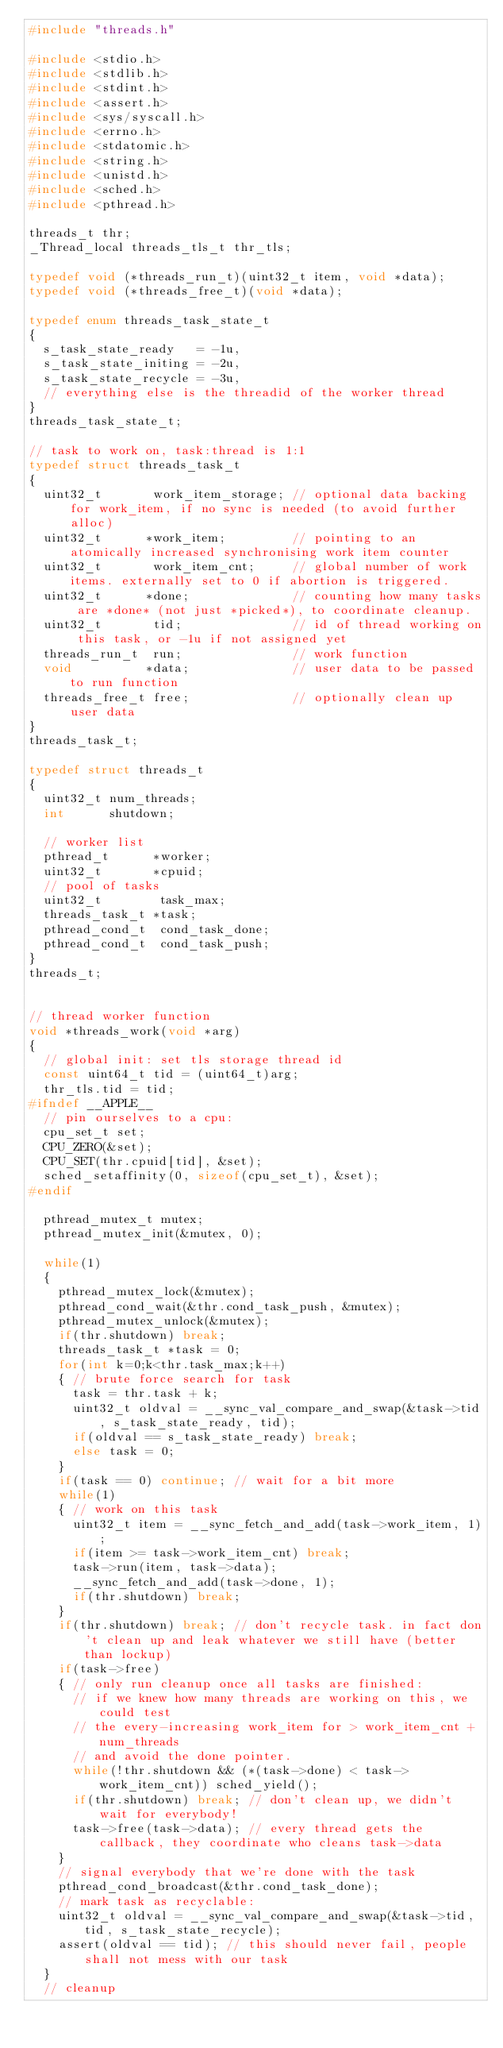<code> <loc_0><loc_0><loc_500><loc_500><_C_>#include "threads.h"

#include <stdio.h>
#include <stdlib.h>
#include <stdint.h>
#include <assert.h>
#include <sys/syscall.h>
#include <errno.h>
#include <stdatomic.h>
#include <string.h>
#include <unistd.h>
#include <sched.h>
#include <pthread.h>

threads_t thr;
_Thread_local threads_tls_t thr_tls;

typedef void (*threads_run_t)(uint32_t item, void *data);
typedef void (*threads_free_t)(void *data);

typedef enum threads_task_state_t
{
  s_task_state_ready   = -1u,
  s_task_state_initing = -2u,
  s_task_state_recycle = -3u,
  // everything else is the threadid of the worker thread
}
threads_task_state_t;

// task to work on, task:thread is 1:1
typedef struct threads_task_t
{
  uint32_t       work_item_storage; // optional data backing for work_item, if no sync is needed (to avoid further alloc)
  uint32_t      *work_item;         // pointing to an atomically increased synchronising work item counter
  uint32_t       work_item_cnt;     // global number of work items. externally set to 0 if abortion is triggered.
  uint32_t      *done;              // counting how many tasks are *done* (not just *picked*), to coordinate cleanup.
  uint32_t       tid;               // id of thread working on this task, or -1u if not assigned yet
  threads_run_t  run;               // work function
  void          *data;              // user data to be passed to run function
  threads_free_t free;              // optionally clean up user data
}
threads_task_t;

typedef struct threads_t
{
  uint32_t num_threads;
  int      shutdown;

  // worker list
  pthread_t      *worker;
  uint32_t       *cpuid;
  // pool of tasks
  uint32_t        task_max;
  threads_task_t *task;
  pthread_cond_t  cond_task_done;
  pthread_cond_t  cond_task_push;
}
threads_t;


// thread worker function
void *threads_work(void *arg)
{
  // global init: set tls storage thread id
  const uint64_t tid = (uint64_t)arg;
  thr_tls.tid = tid;
#ifndef __APPLE__
  // pin ourselves to a cpu:
  cpu_set_t set;
  CPU_ZERO(&set);
  CPU_SET(thr.cpuid[tid], &set);
  sched_setaffinity(0, sizeof(cpu_set_t), &set);
#endif

  pthread_mutex_t mutex;
  pthread_mutex_init(&mutex, 0);

  while(1)
  {
    pthread_mutex_lock(&mutex);
    pthread_cond_wait(&thr.cond_task_push, &mutex);
    pthread_mutex_unlock(&mutex);
    if(thr.shutdown) break;
    threads_task_t *task = 0;
    for(int k=0;k<thr.task_max;k++)
    { // brute force search for task
      task = thr.task + k;
      uint32_t oldval = __sync_val_compare_and_swap(&task->tid, s_task_state_ready, tid);
      if(oldval == s_task_state_ready) break;
      else task = 0;
    }
    if(task == 0) continue; // wait for a bit more
    while(1)
    { // work on this task
      uint32_t item = __sync_fetch_and_add(task->work_item, 1);
      if(item >= task->work_item_cnt) break;
      task->run(item, task->data);
      __sync_fetch_and_add(task->done, 1);
      if(thr.shutdown) break;
    }
    if(thr.shutdown) break; // don't recycle task. in fact don't clean up and leak whatever we still have (better than lockup)
    if(task->free)
    { // only run cleanup once all tasks are finished:
      // if we knew how many threads are working on this, we could test
      // the every-increasing work_item for > work_item_cnt + num_threads
      // and avoid the done pointer.
      while(!thr.shutdown && (*(task->done) < task->work_item_cnt)) sched_yield();
      if(thr.shutdown) break; // don't clean up, we didn't wait for everybody!
      task->free(task->data); // every thread gets the callback, they coordinate who cleans task->data
    }
    // signal everybody that we're done with the task
    pthread_cond_broadcast(&thr.cond_task_done);
    // mark task as recyclable:
    uint32_t oldval = __sync_val_compare_and_swap(&task->tid, tid, s_task_state_recycle);
    assert(oldval == tid); // this should never fail, people shall not mess with our task
  }
  // cleanup</code> 